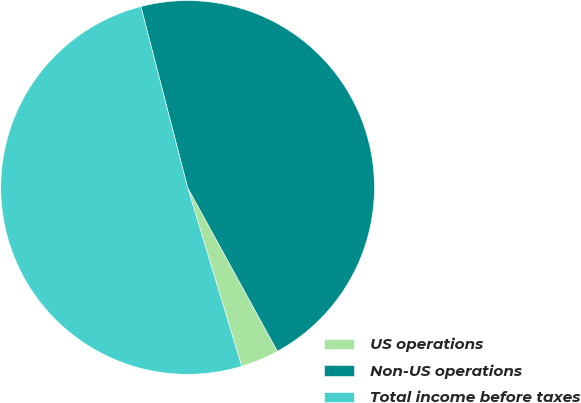<chart> <loc_0><loc_0><loc_500><loc_500><pie_chart><fcel>US operations<fcel>Non-US operations<fcel>Total income before taxes<nl><fcel>3.31%<fcel>46.04%<fcel>50.65%<nl></chart> 